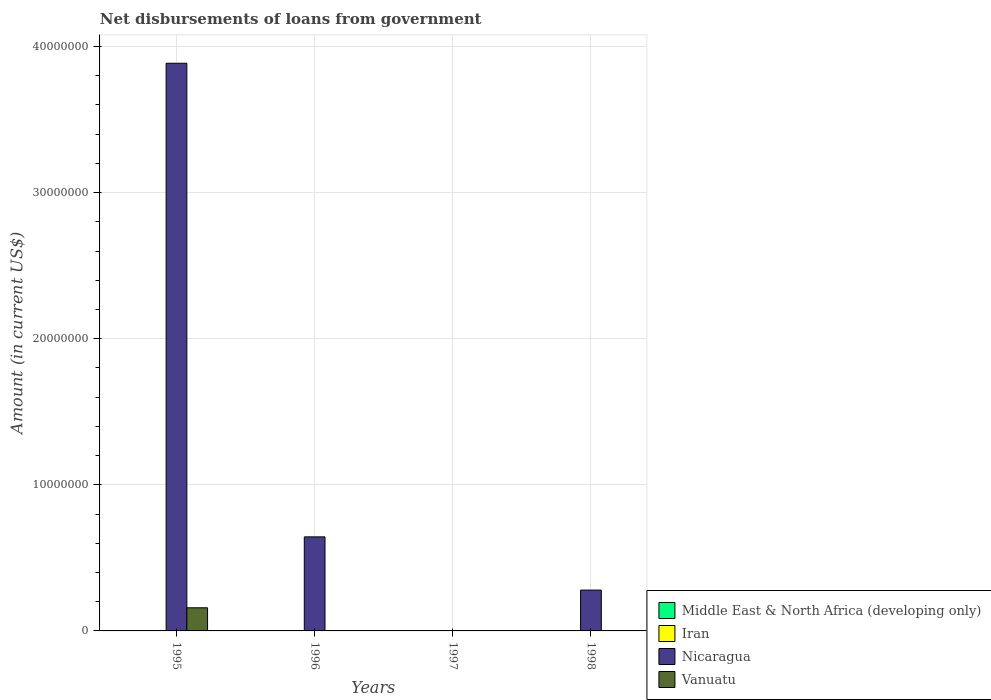How many different coloured bars are there?
Provide a short and direct response. 2. How many bars are there on the 4th tick from the left?
Offer a terse response. 1. How many bars are there on the 3rd tick from the right?
Make the answer very short. 1. Across all years, what is the maximum amount of loan disbursed from government in Vanuatu?
Keep it short and to the point. 1.58e+06. In which year was the amount of loan disbursed from government in Vanuatu maximum?
Offer a terse response. 1995. What is the total amount of loan disbursed from government in Nicaragua in the graph?
Your answer should be compact. 4.81e+07. What is the difference between the amount of loan disbursed from government in Middle East & North Africa (developing only) in 1997 and the amount of loan disbursed from government in Iran in 1995?
Your answer should be compact. 0. What is the average amount of loan disbursed from government in Middle East & North Africa (developing only) per year?
Offer a very short reply. 0. What is the ratio of the amount of loan disbursed from government in Nicaragua in 1995 to that in 1998?
Your answer should be very brief. 13.9. What is the difference between the highest and the second highest amount of loan disbursed from government in Nicaragua?
Provide a succinct answer. 3.24e+07. What is the difference between the highest and the lowest amount of loan disbursed from government in Vanuatu?
Give a very brief answer. 1.58e+06. In how many years, is the amount of loan disbursed from government in Nicaragua greater than the average amount of loan disbursed from government in Nicaragua taken over all years?
Offer a terse response. 1. Is it the case that in every year, the sum of the amount of loan disbursed from government in Middle East & North Africa (developing only) and amount of loan disbursed from government in Nicaragua is greater than the amount of loan disbursed from government in Iran?
Make the answer very short. No. How many bars are there?
Offer a very short reply. 4. Are all the bars in the graph horizontal?
Your answer should be compact. No. How many years are there in the graph?
Keep it short and to the point. 4. Are the values on the major ticks of Y-axis written in scientific E-notation?
Make the answer very short. No. Where does the legend appear in the graph?
Your response must be concise. Bottom right. How many legend labels are there?
Your answer should be very brief. 4. How are the legend labels stacked?
Ensure brevity in your answer.  Vertical. What is the title of the graph?
Make the answer very short. Net disbursements of loans from government. What is the Amount (in current US$) in Middle East & North Africa (developing only) in 1995?
Make the answer very short. 0. What is the Amount (in current US$) in Iran in 1995?
Your response must be concise. 0. What is the Amount (in current US$) of Nicaragua in 1995?
Keep it short and to the point. 3.89e+07. What is the Amount (in current US$) in Vanuatu in 1995?
Give a very brief answer. 1.58e+06. What is the Amount (in current US$) in Middle East & North Africa (developing only) in 1996?
Offer a very short reply. 0. What is the Amount (in current US$) in Nicaragua in 1996?
Your answer should be compact. 6.44e+06. What is the Amount (in current US$) of Vanuatu in 1996?
Ensure brevity in your answer.  0. What is the Amount (in current US$) of Middle East & North Africa (developing only) in 1997?
Make the answer very short. 0. What is the Amount (in current US$) in Iran in 1997?
Provide a succinct answer. 0. What is the Amount (in current US$) of Nicaragua in 1997?
Keep it short and to the point. 0. What is the Amount (in current US$) in Middle East & North Africa (developing only) in 1998?
Offer a terse response. 0. What is the Amount (in current US$) of Nicaragua in 1998?
Ensure brevity in your answer.  2.80e+06. What is the Amount (in current US$) in Vanuatu in 1998?
Your answer should be compact. 0. Across all years, what is the maximum Amount (in current US$) in Nicaragua?
Ensure brevity in your answer.  3.89e+07. Across all years, what is the maximum Amount (in current US$) in Vanuatu?
Provide a succinct answer. 1.58e+06. Across all years, what is the minimum Amount (in current US$) in Vanuatu?
Your answer should be very brief. 0. What is the total Amount (in current US$) in Middle East & North Africa (developing only) in the graph?
Keep it short and to the point. 0. What is the total Amount (in current US$) of Iran in the graph?
Offer a very short reply. 0. What is the total Amount (in current US$) in Nicaragua in the graph?
Provide a succinct answer. 4.81e+07. What is the total Amount (in current US$) in Vanuatu in the graph?
Make the answer very short. 1.58e+06. What is the difference between the Amount (in current US$) of Nicaragua in 1995 and that in 1996?
Provide a succinct answer. 3.24e+07. What is the difference between the Amount (in current US$) of Nicaragua in 1995 and that in 1998?
Offer a very short reply. 3.61e+07. What is the difference between the Amount (in current US$) in Nicaragua in 1996 and that in 1998?
Your answer should be compact. 3.64e+06. What is the average Amount (in current US$) of Iran per year?
Provide a short and direct response. 0. What is the average Amount (in current US$) in Nicaragua per year?
Make the answer very short. 1.20e+07. What is the average Amount (in current US$) in Vanuatu per year?
Offer a terse response. 3.96e+05. In the year 1995, what is the difference between the Amount (in current US$) in Nicaragua and Amount (in current US$) in Vanuatu?
Give a very brief answer. 3.73e+07. What is the ratio of the Amount (in current US$) of Nicaragua in 1995 to that in 1996?
Make the answer very short. 6.04. What is the ratio of the Amount (in current US$) of Nicaragua in 1995 to that in 1998?
Make the answer very short. 13.9. What is the ratio of the Amount (in current US$) of Nicaragua in 1996 to that in 1998?
Make the answer very short. 2.3. What is the difference between the highest and the second highest Amount (in current US$) of Nicaragua?
Give a very brief answer. 3.24e+07. What is the difference between the highest and the lowest Amount (in current US$) of Nicaragua?
Make the answer very short. 3.89e+07. What is the difference between the highest and the lowest Amount (in current US$) of Vanuatu?
Offer a terse response. 1.58e+06. 